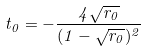<formula> <loc_0><loc_0><loc_500><loc_500>t _ { 0 } = - \frac { 4 \sqrt { r _ { 0 } } } { ( 1 - \sqrt { r _ { 0 } } ) ^ { 2 } }</formula> 